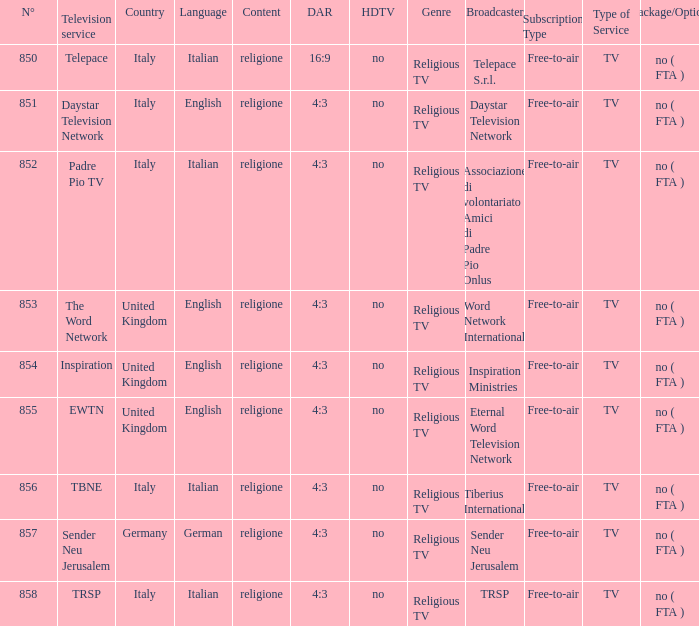What television service is in italy and is in english? Daystar Television Network. 